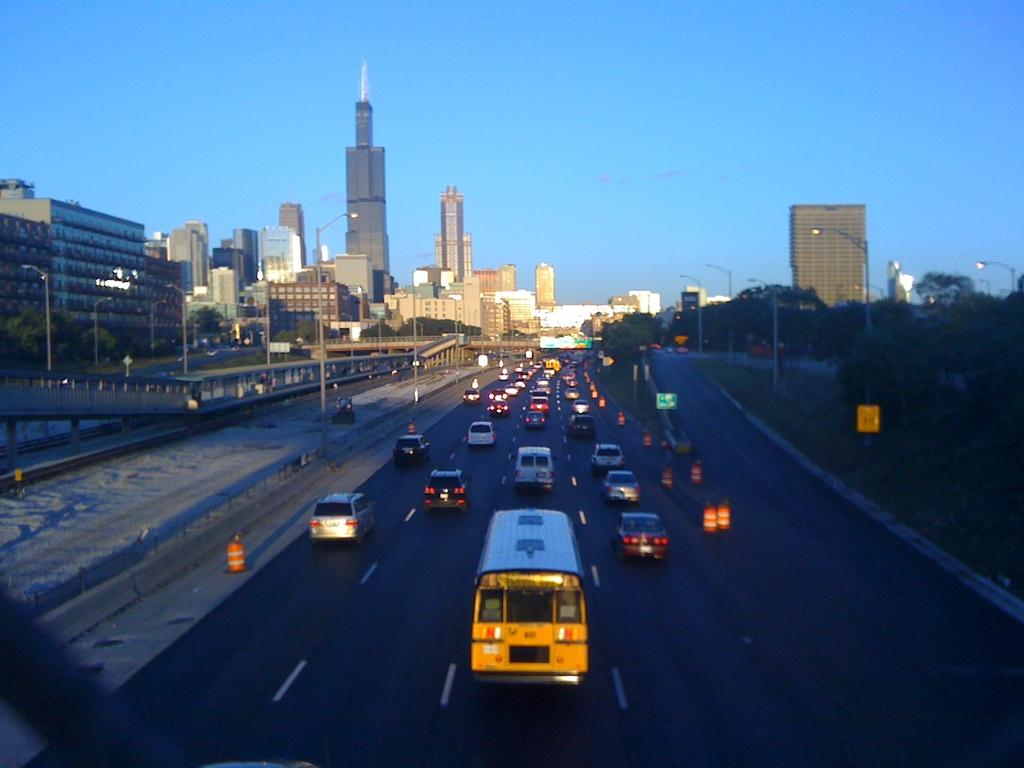What can be seen on the road in the image? There are vehicles on the road in the image. What is located on the left side of the image? There are buildings on the left side of the image. What type of vegetation is on the right side of the image? There are trees on the right side of the image. What is the opinion of the chain on the street in the image? There is no chain or street present in the image, so it is not possible to determine an opinion. 